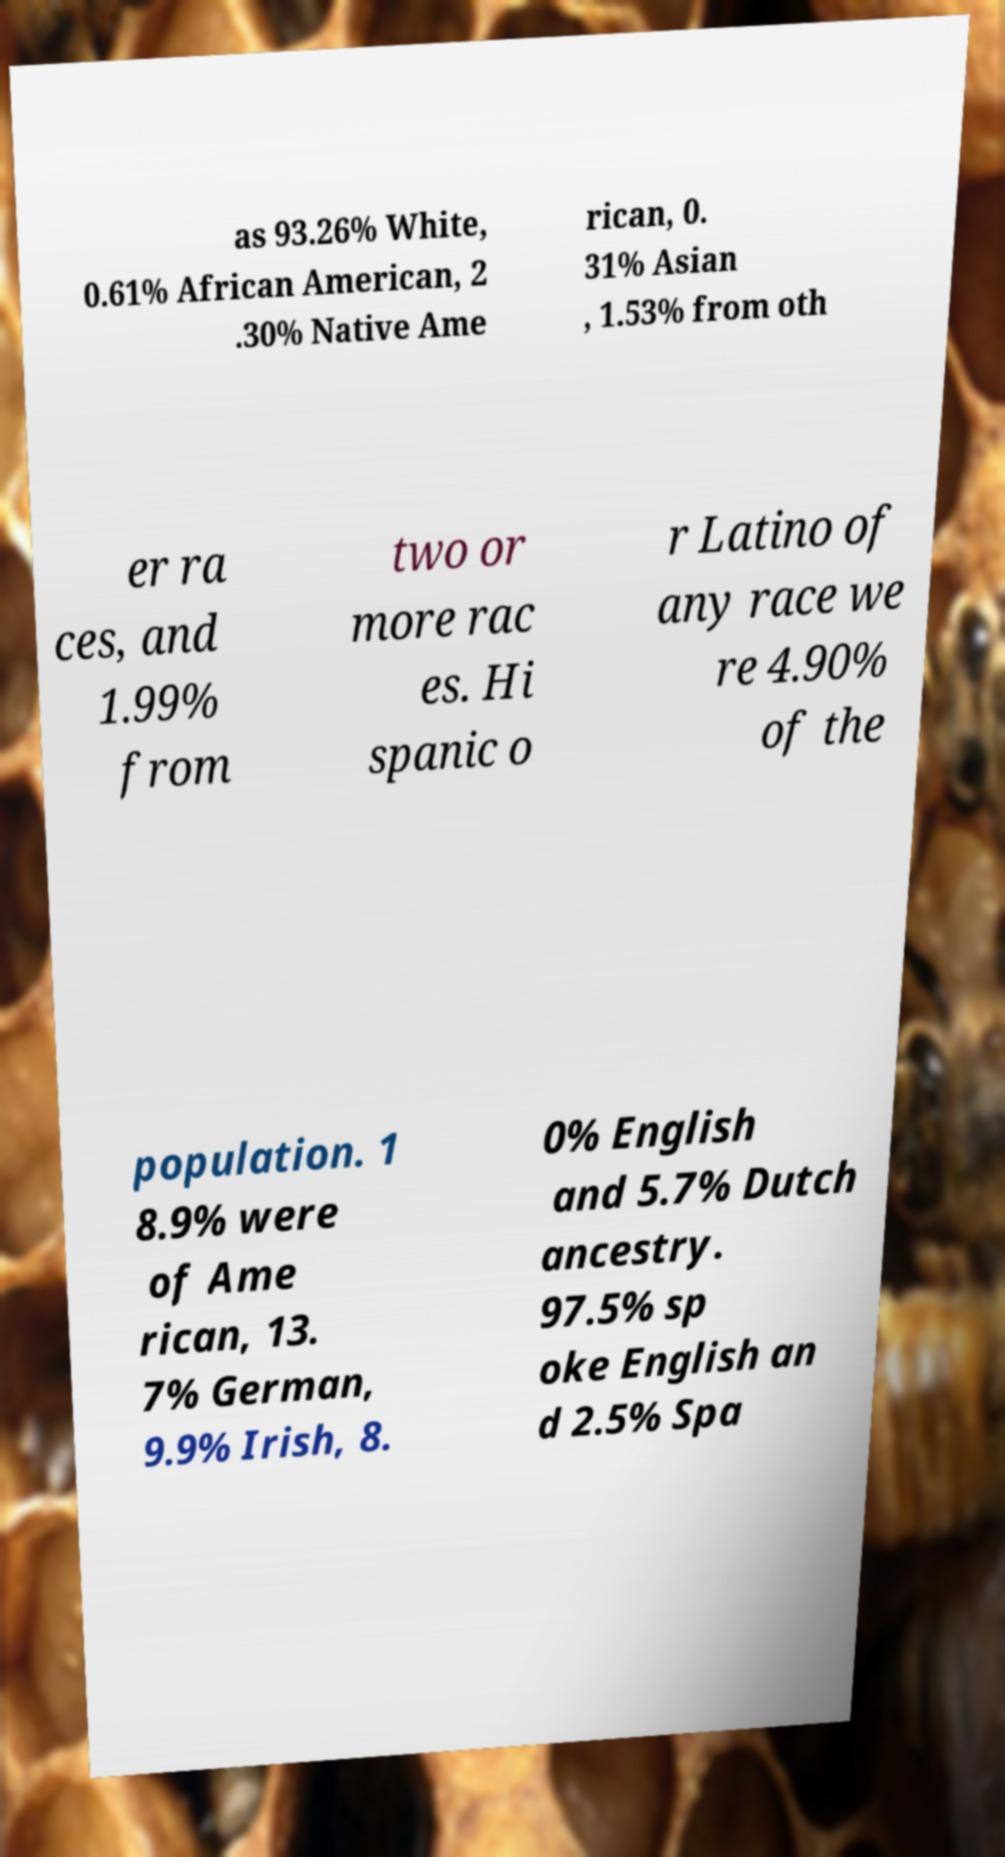Please identify and transcribe the text found in this image. as 93.26% White, 0.61% African American, 2 .30% Native Ame rican, 0. 31% Asian , 1.53% from oth er ra ces, and 1.99% from two or more rac es. Hi spanic o r Latino of any race we re 4.90% of the population. 1 8.9% were of Ame rican, 13. 7% German, 9.9% Irish, 8. 0% English and 5.7% Dutch ancestry. 97.5% sp oke English an d 2.5% Spa 